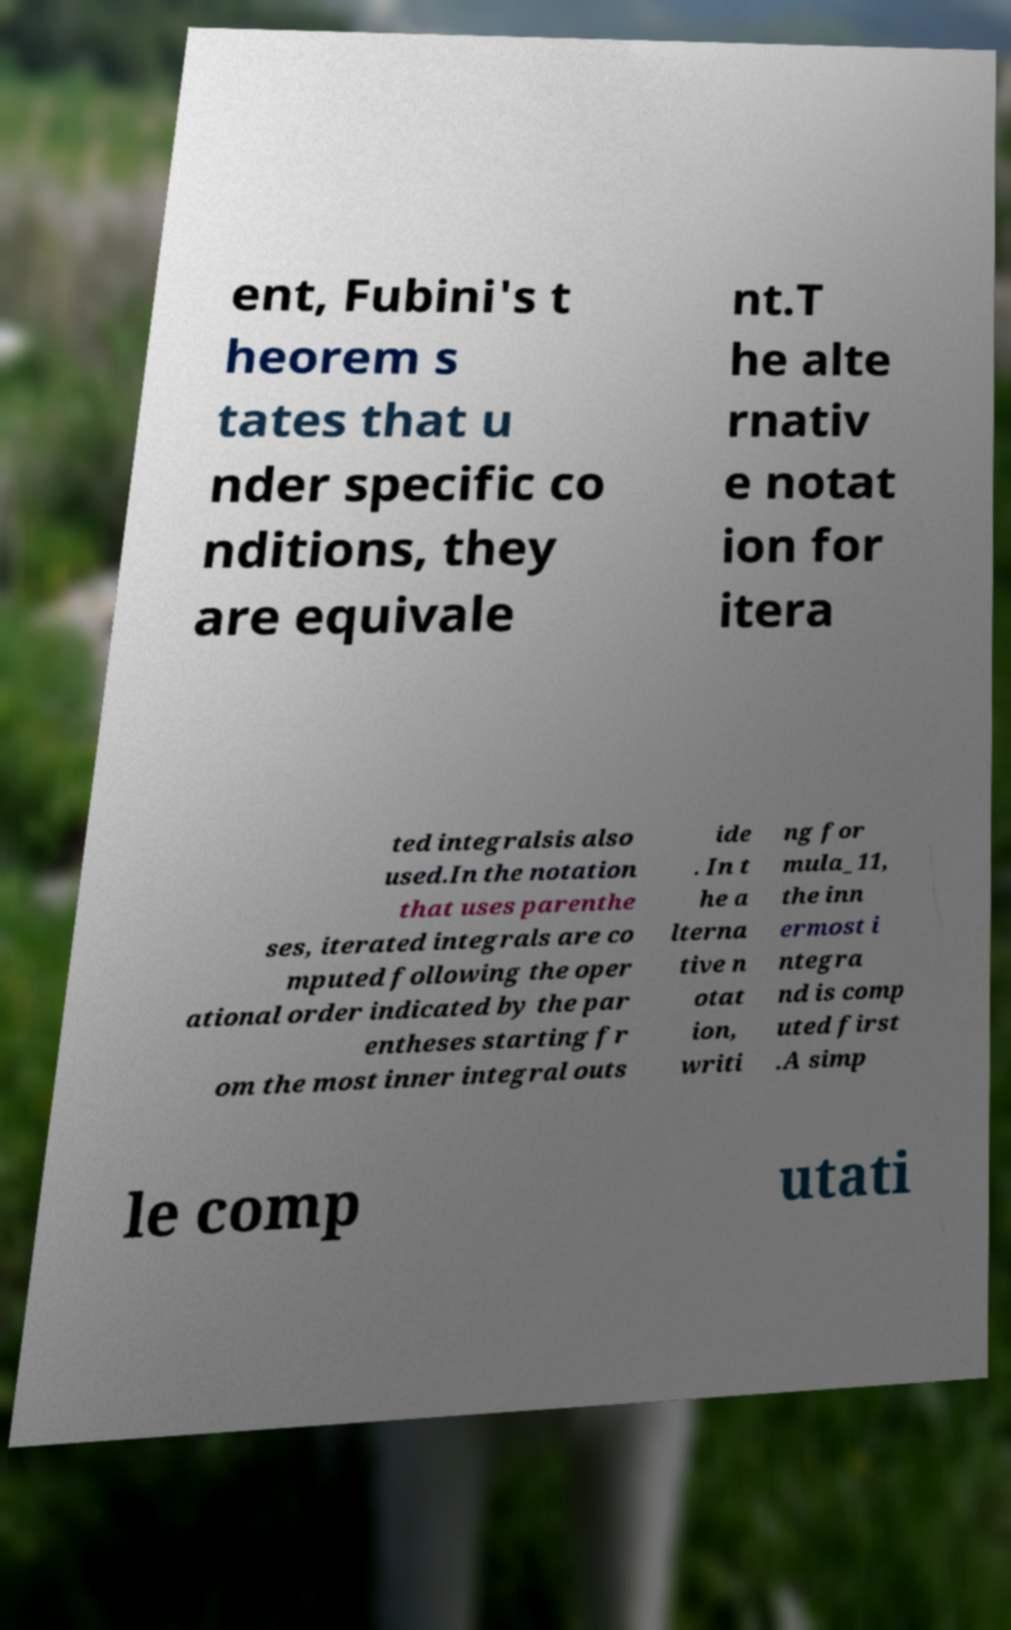I need the written content from this picture converted into text. Can you do that? ent, Fubini's t heorem s tates that u nder specific co nditions, they are equivale nt.T he alte rnativ e notat ion for itera ted integralsis also used.In the notation that uses parenthe ses, iterated integrals are co mputed following the oper ational order indicated by the par entheses starting fr om the most inner integral outs ide . In t he a lterna tive n otat ion, writi ng for mula_11, the inn ermost i ntegra nd is comp uted first .A simp le comp utati 